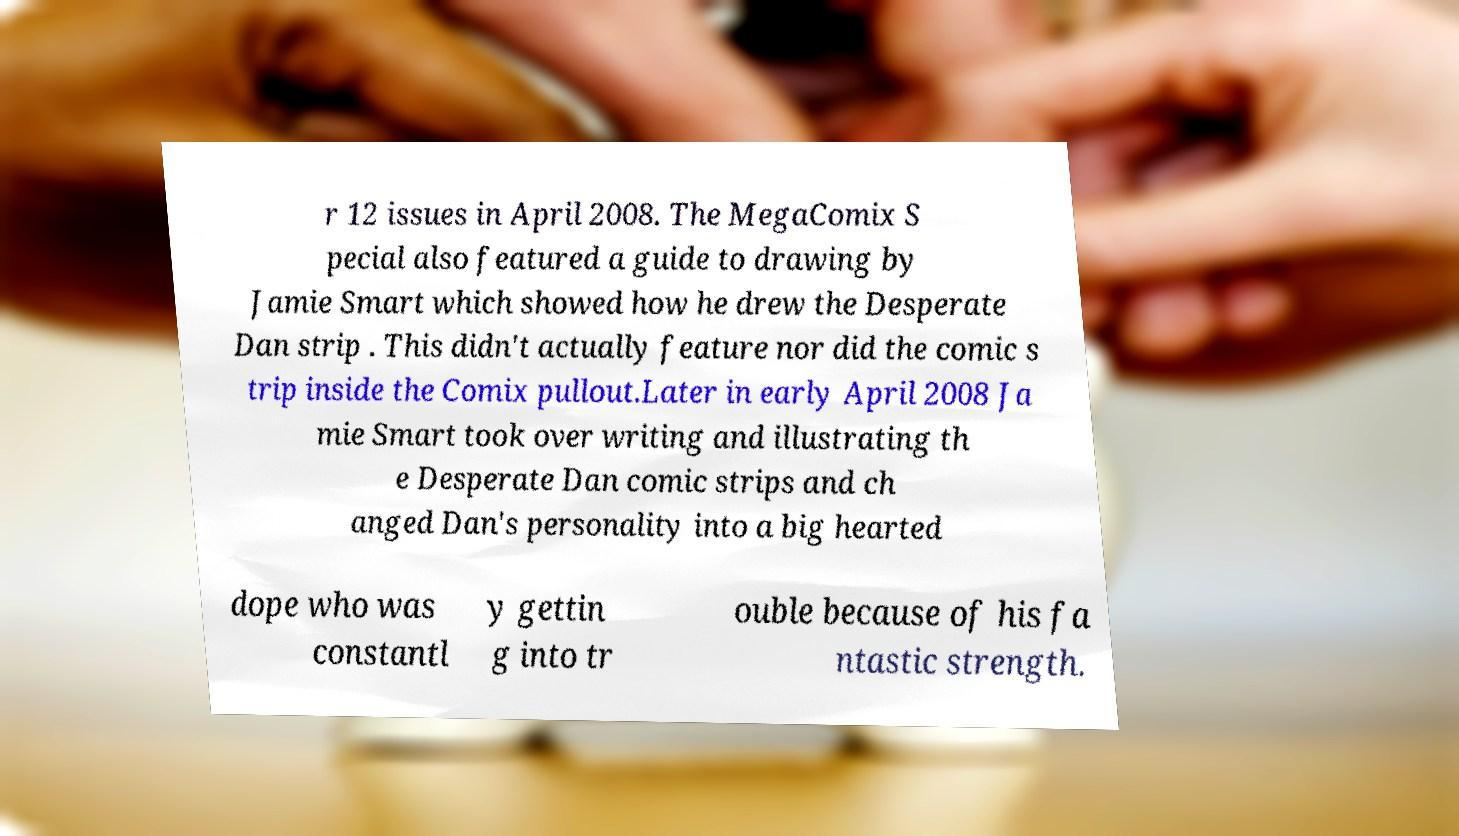Can you accurately transcribe the text from the provided image for me? r 12 issues in April 2008. The MegaComix S pecial also featured a guide to drawing by Jamie Smart which showed how he drew the Desperate Dan strip . This didn't actually feature nor did the comic s trip inside the Comix pullout.Later in early April 2008 Ja mie Smart took over writing and illustrating th e Desperate Dan comic strips and ch anged Dan's personality into a big hearted dope who was constantl y gettin g into tr ouble because of his fa ntastic strength. 